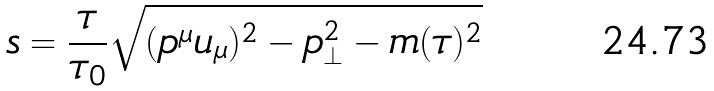Convert formula to latex. <formula><loc_0><loc_0><loc_500><loc_500>s = \frac { \tau } { \tau _ { 0 } } \sqrt { ( p ^ { \mu } u _ { \mu } ) ^ { 2 } - p _ { \bot } ^ { 2 } - m ( \tau ) ^ { 2 } } \</formula> 